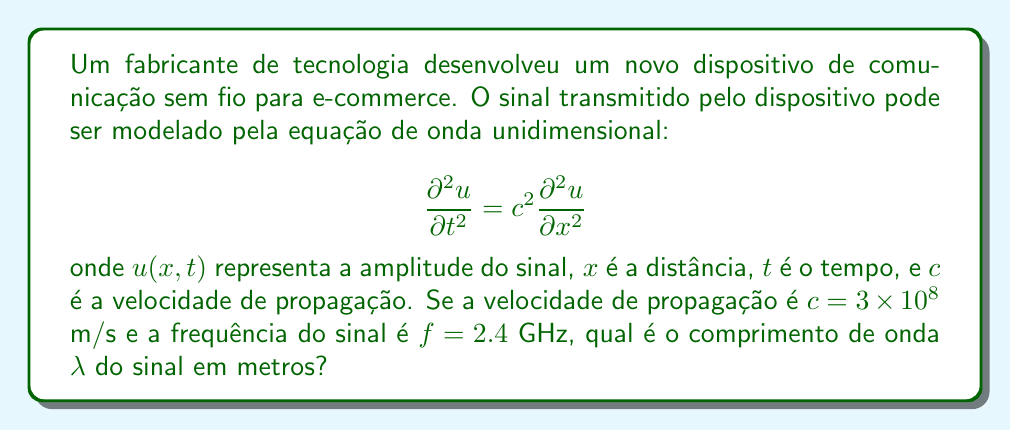Teach me how to tackle this problem. Para resolver este problema, seguiremos os seguintes passos:

1) Primeiro, lembremos a relação fundamental entre velocidade de propagação ($c$), frequência ($f$) e comprimento de onda ($\lambda$):

   $$c = f \lambda$$

2) Neste caso, temos:
   $c = 3 \times 10^8$ m/s
   $f = 2.4$ GHz = $2.4 \times 10^9$ Hz

3) Substituindo estes valores na equação:

   $$3 \times 10^8 = (2.4 \times 10^9) \lambda$$

4) Agora, resolvemos para $\lambda$:

   $$\lambda = \frac{3 \times 10^8}{2.4 \times 10^9}$$

5) Simplificando:

   $$\lambda = \frac{3}{2.4} \times \frac{10^8}{10^9} = 0.125 \times 10^{-1} = 0.125 \times 10^{-1}$$ m

6) Convertendo para centímetros para uma melhor compreensão:

   $$\lambda = 12.5$$ cm

Portanto, o comprimento de onda do sinal é 0.125 metros ou 12.5 centímetros.
Answer: $\lambda = 0.125$ m 